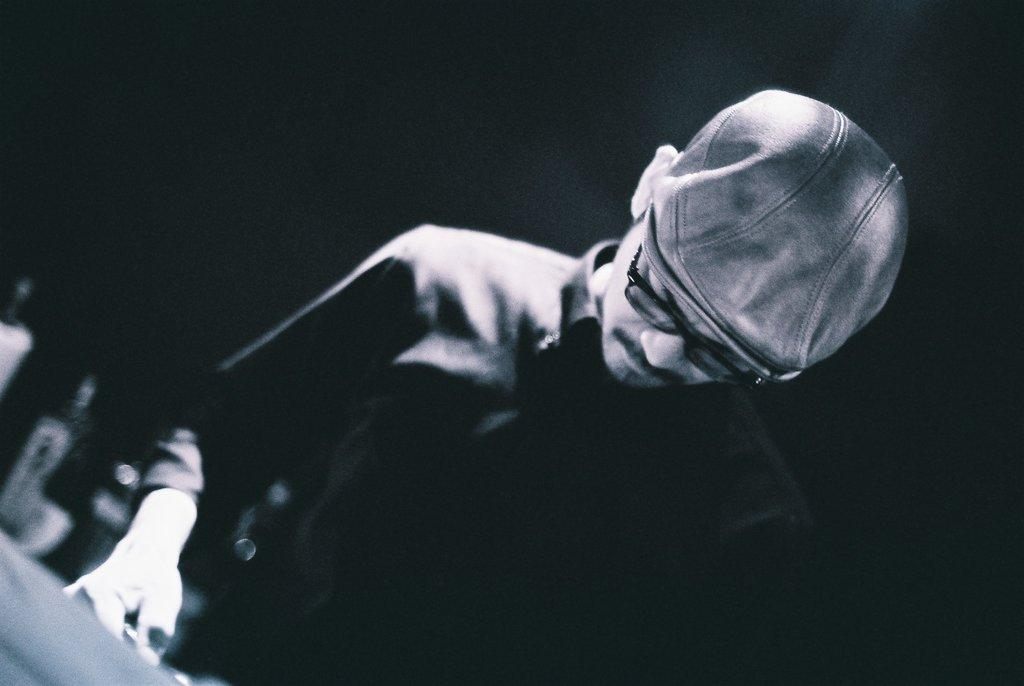What is the color scheme of the image? The image is black and white. Who is present in the image? There is a man in the image. What is the man wearing on his head? The man is wearing a cap. What accessory is the man wearing on his face? The man is wearing spectacles. What can be observed about the background of the image? The background of the image is dark. What else can be seen in the image besides the man? There are objects visible in the image. What type of territory is the man trying to claim in the image? There is no indication of territory or any claim in the image; it simply features a man wearing a cap and spectacles. Can you tell me how many times the man has bitten his nails in the image? There is no indication of the man biting his nails or any hand gestures in the image. 